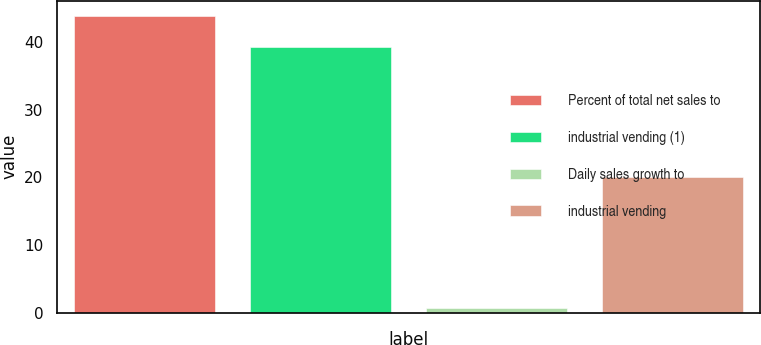<chart> <loc_0><loc_0><loc_500><loc_500><bar_chart><fcel>Percent of total net sales to<fcel>industrial vending (1)<fcel>Daily sales growth to<fcel>industrial vending<nl><fcel>43.9<fcel>39.3<fcel>0.7<fcel>20<nl></chart> 